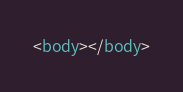Convert code to text. <code><loc_0><loc_0><loc_500><loc_500><_HTML_><body></body>

</code> 